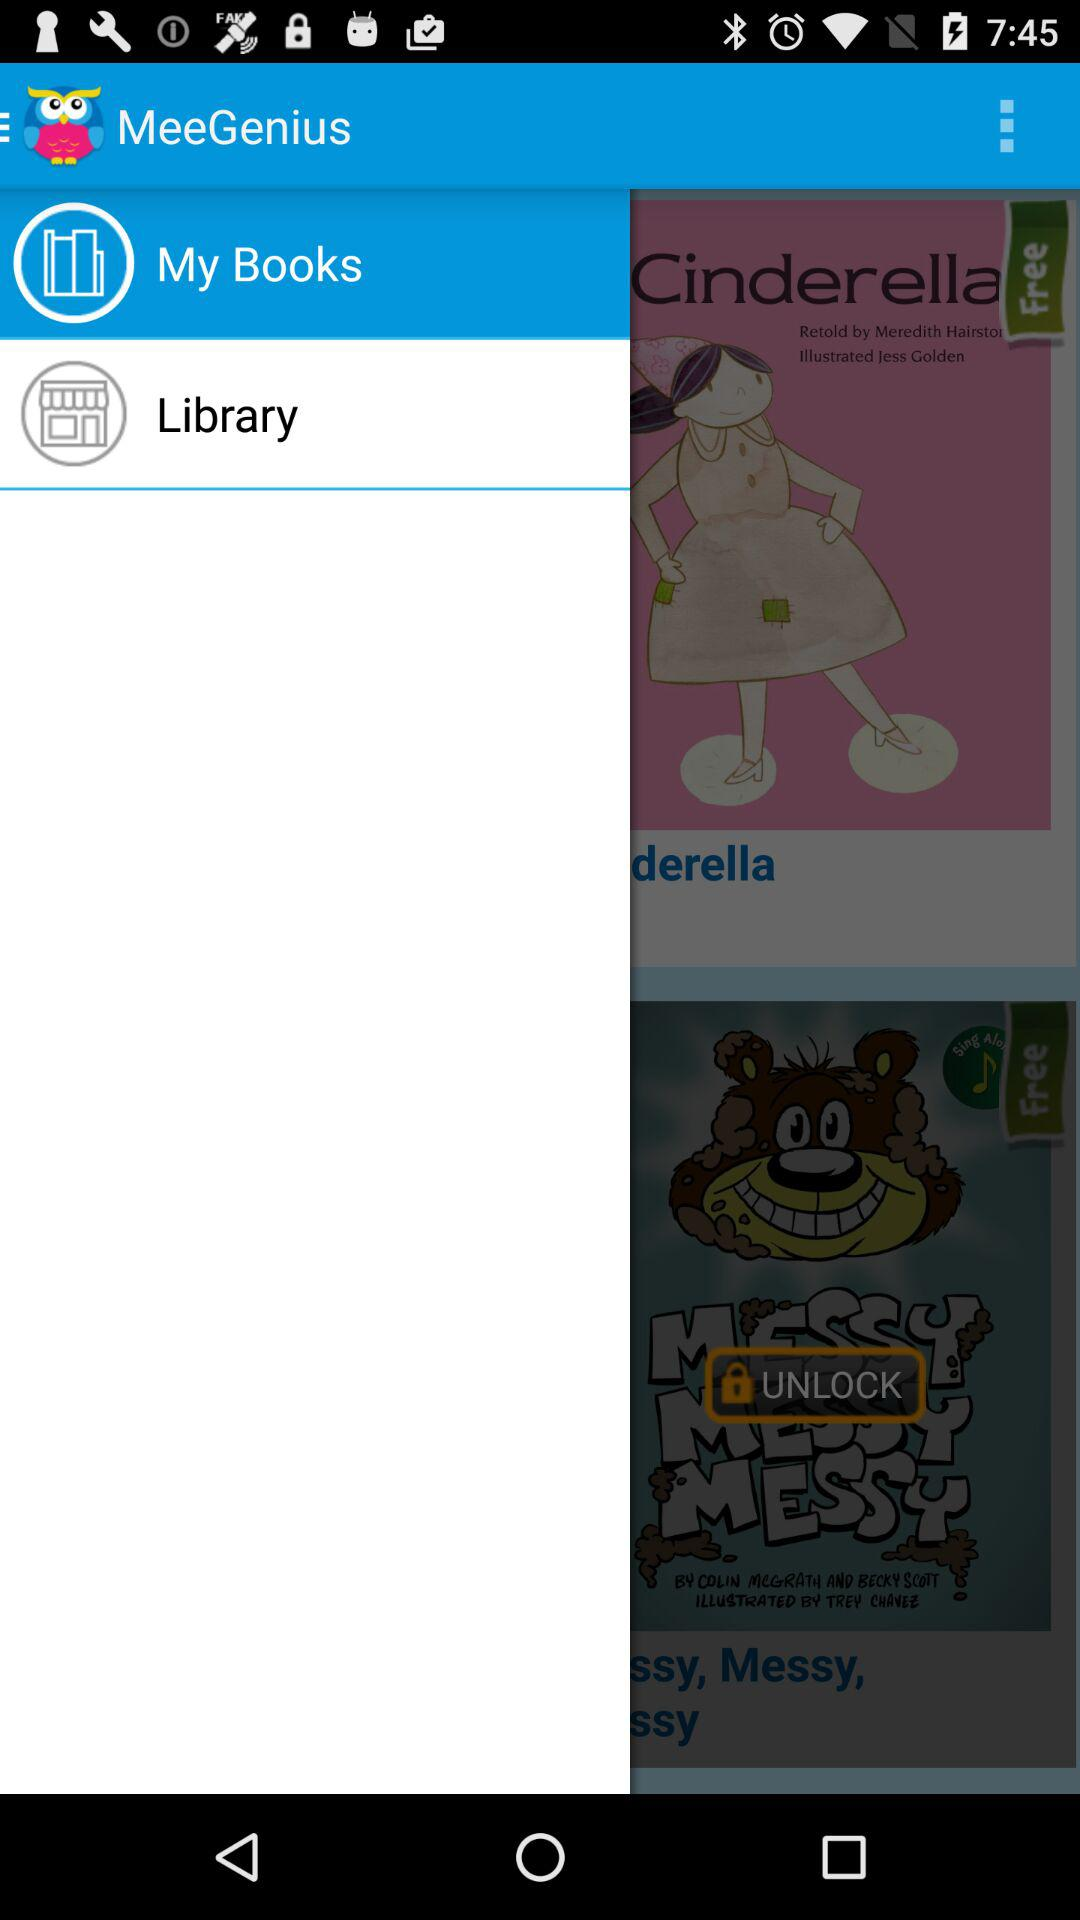What is the selected option? The selected option is "My Book". 